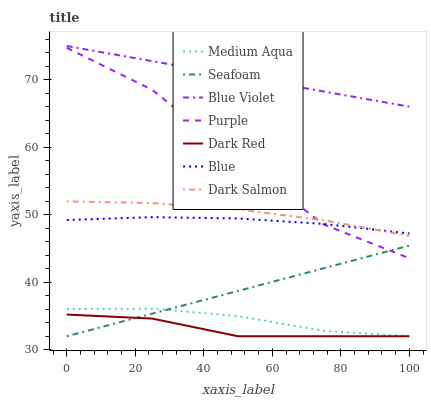Does Purple have the minimum area under the curve?
Answer yes or no. No. Does Purple have the maximum area under the curve?
Answer yes or no. No. Is Dark Red the smoothest?
Answer yes or no. No. Is Dark Red the roughest?
Answer yes or no. No. Does Purple have the lowest value?
Answer yes or no. No. Does Purple have the highest value?
Answer yes or no. No. Is Medium Aqua less than Dark Salmon?
Answer yes or no. Yes. Is Blue Violet greater than Dark Red?
Answer yes or no. Yes. Does Medium Aqua intersect Dark Salmon?
Answer yes or no. No. 